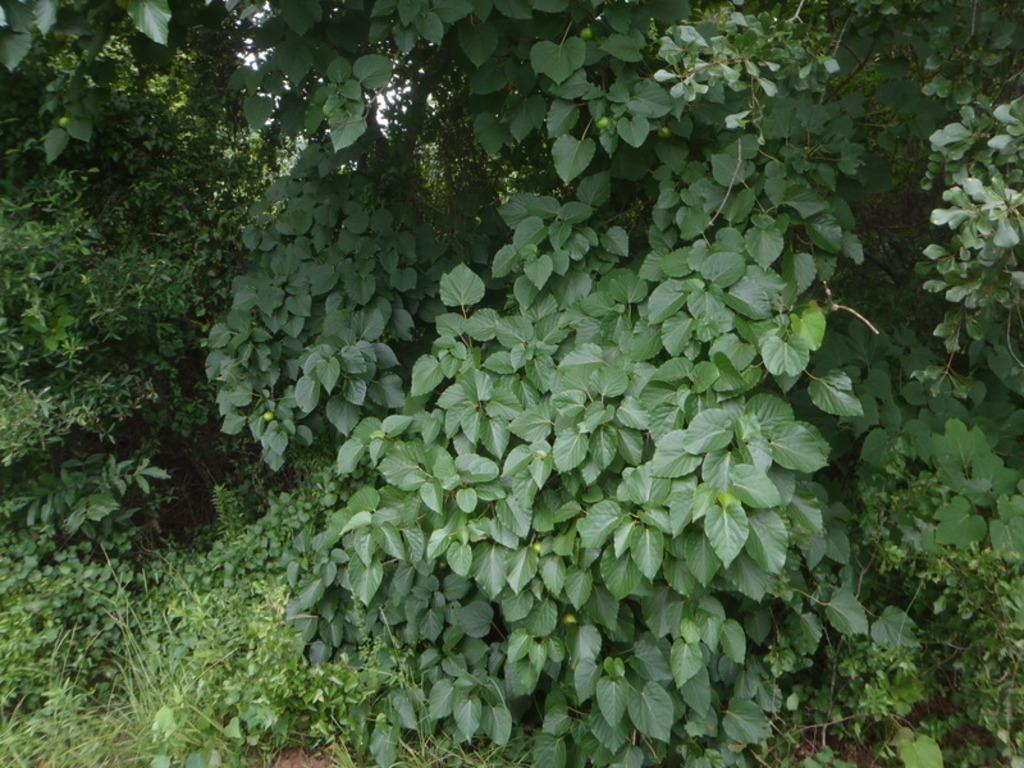What type of ground cover is visible in the image? There is grass on the ground in the image. What other types of vegetation can be seen in the image? There are plants and trees in the image. What type of vest is being worn by the kettle in the image? There is no kettle or vest present in the image. 